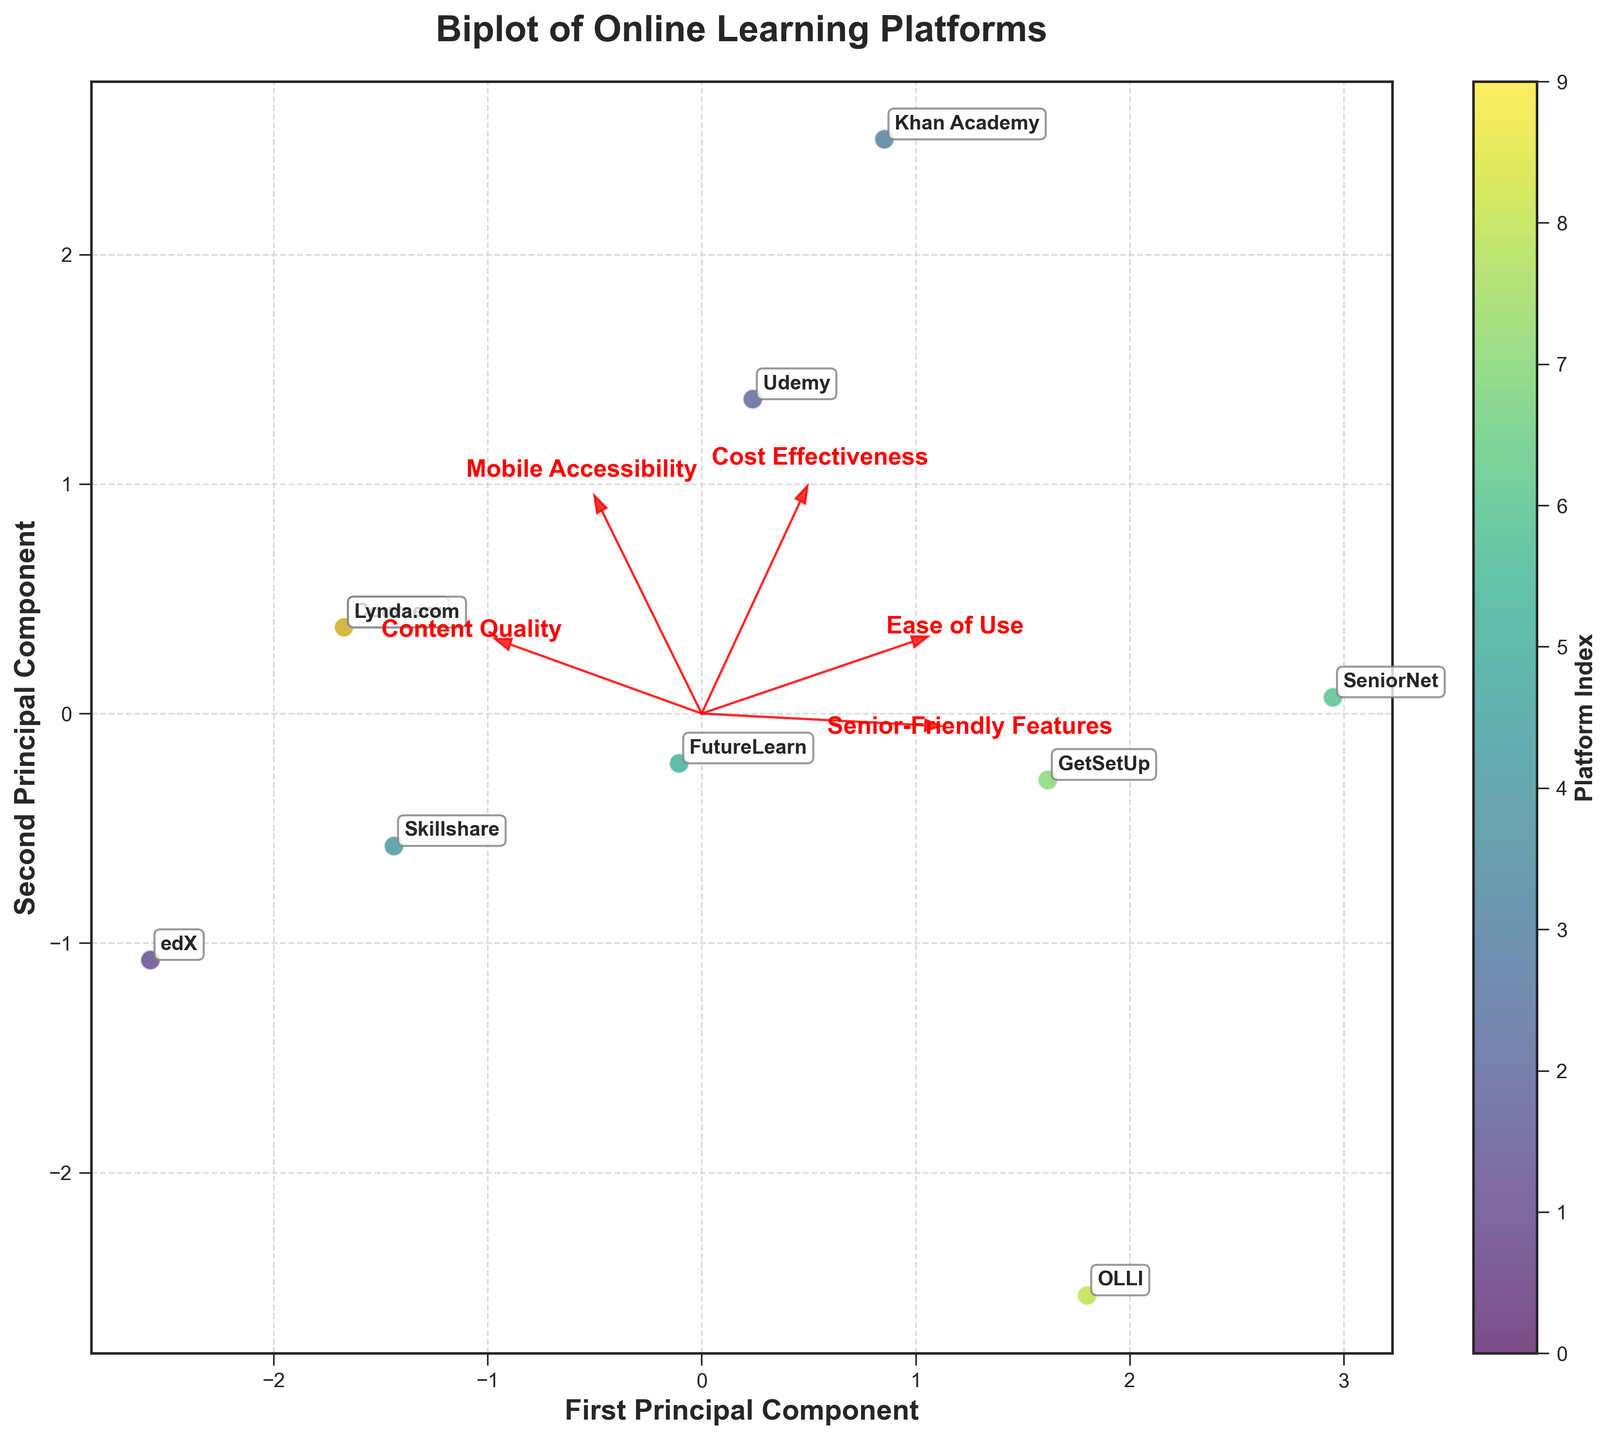What do the axes represent in this plot? The plot shows the first two principal components from the PCA. The x-axis represents the First Principal Component, and the y-axis represents the Second Principal Component.
Answer: First and Second Principal Components Which platform appears the closest to the 'Ease of Use' feature vector? To determine which platform is closest to the 'Ease of Use' feature vector, look for the platform point closest to the arrow labeled 'Ease of Use.'
Answer: Khan Academy How many platforms are analyzed in this graph? Count the number of distinct data points labeled with platform names on the graph.
Answer: 10 Which platform seems to have the highest score along the first principal component? Compare the positions of all platforms along the x-axis (First Principal Component), and identify the one that is furthest to the right.
Answer: Khan Academy Do costs affect the positions of the platforms in the plot? Analyze the direction of the 'Cost Effectiveness' vector in relation to the platforms. The 'Cost Effectiveness' vector points towards platforms on the right, indicating those platforms are considered cost-effective.
Answer: Yes Which platforms are strongly associated with each other according to clustering on the plot? Identify the platforms that are closely positioned near each other. Clusters on the plot indicate strong association.
Answer: Lynda.com and Coursera Which feature seems to have more influence along the second principal component? Observe which feature vector stretches more along the y-axis (Second Principal Component).
Answer: Content Quality Is there a platform that is distinctly out of the main cluster in the plot? Identify any platform that is positioned far from the main grouping of other platforms.
Answer: SeniorNet What does the 'Mobile Accessibility' vector indicate about the platform positions? Look at the direction and length of the 'Mobile Accessibility' vector. Platforms positioned in the direction of this arrow are associated with good mobile accessibility.
Answer: Strong mobile accessibility for platforms in that direction Which vector appears to be most aligned with the first principal component? The vector most aligned with the first principal component (x-axis) would stretch along the x-axis direction.
Answer: Senior-Friendly Features 